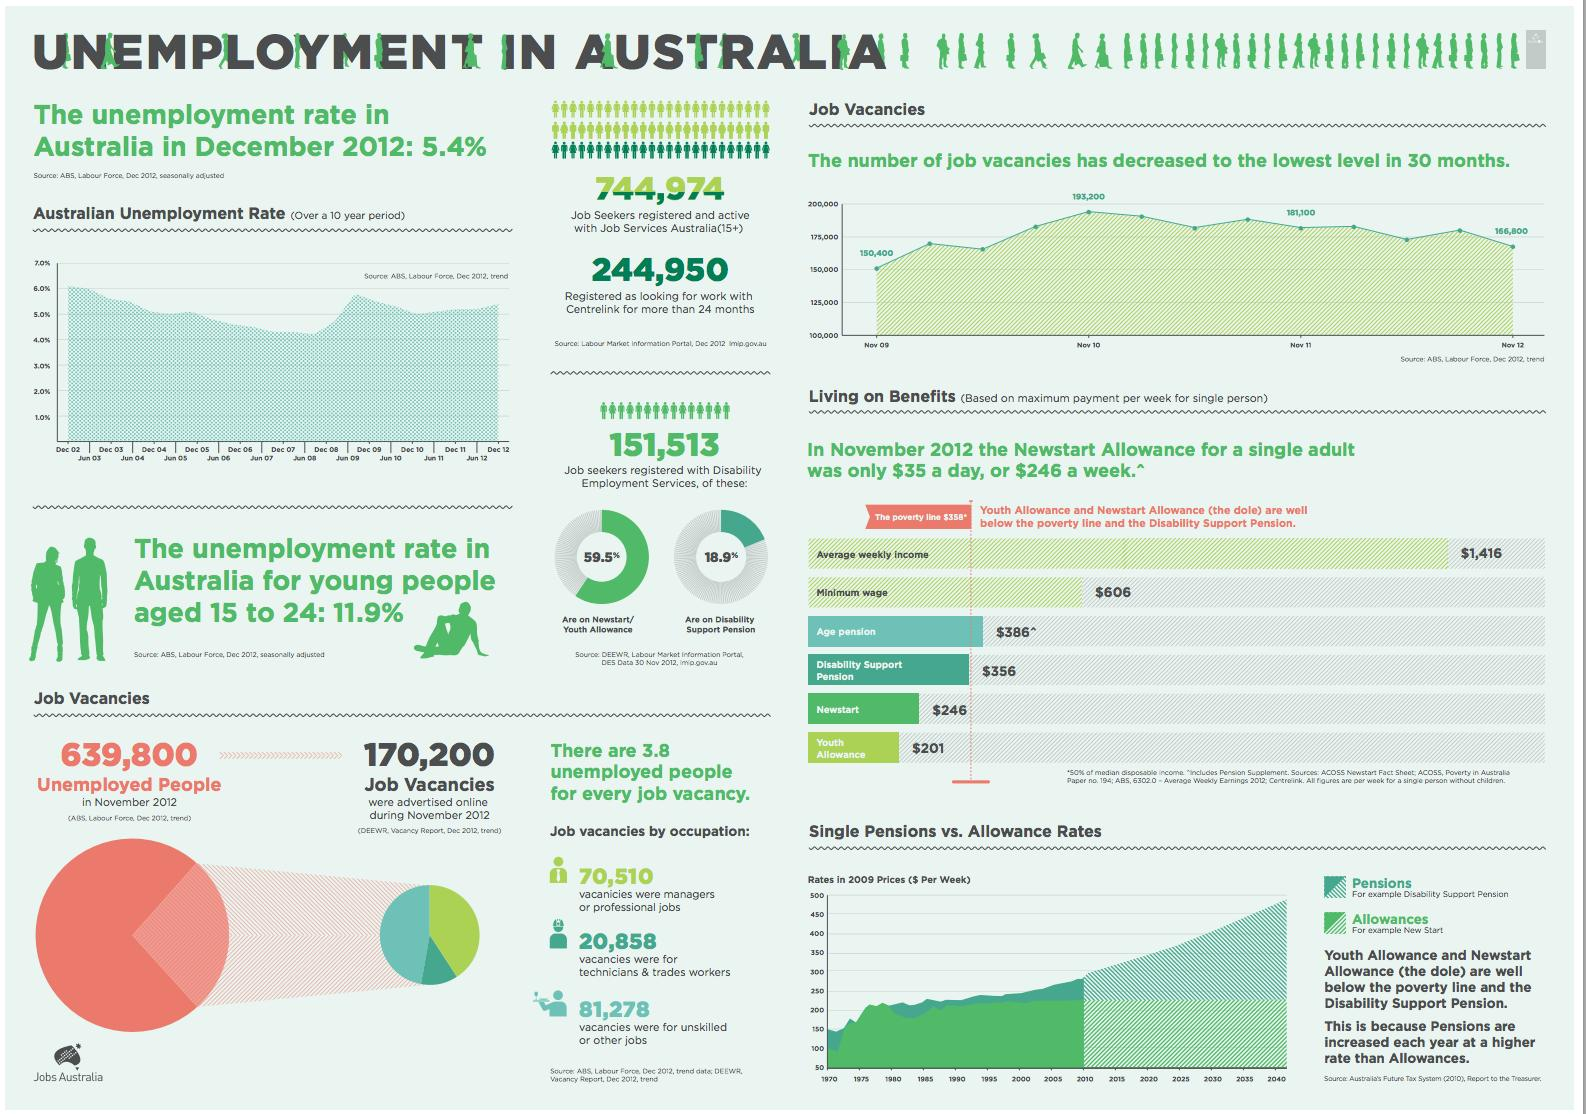Identify some key points in this picture. In 2012, a significant proportion of job seekers registered with Disability Employment Services in Australia received Newstart or Youth Allowance, with 59.5% of job seekers falling into this category. In 2012, there were 70,510 vacancies for managerial and professional jobs in Australia. In 2012, 18.9% of job seekers registered with Disability Employment Services in Australia were also receiving Disability Support Pension. In 2012, there were 20,858 vacancies for technicians and trade workers in Australia. 